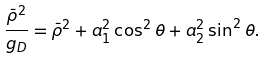<formula> <loc_0><loc_0><loc_500><loc_500>\frac { \bar { \rho } ^ { 2 } } { g _ { D } } = \bar { \rho } ^ { 2 } + a _ { 1 } ^ { 2 } \cos ^ { 2 } \theta + a _ { 2 } ^ { 2 } \sin ^ { 2 } \theta .</formula> 